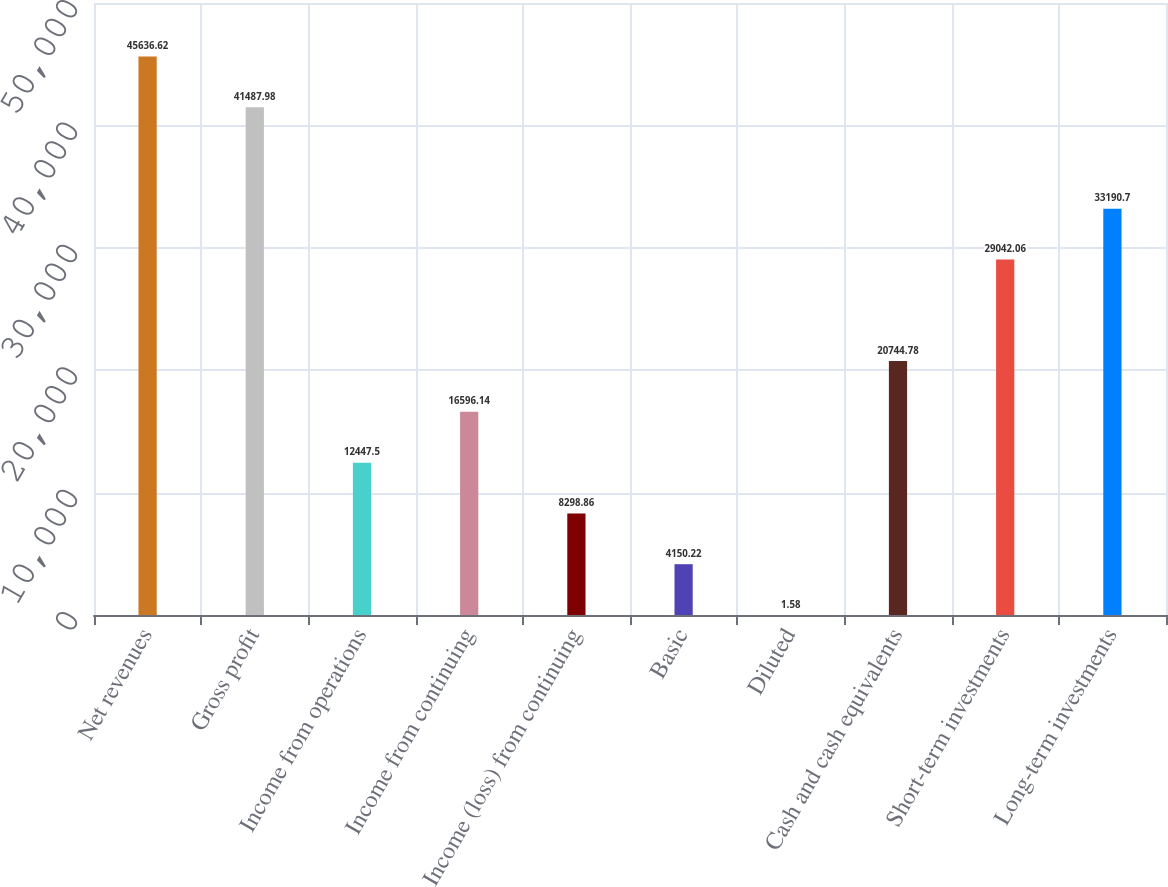<chart> <loc_0><loc_0><loc_500><loc_500><bar_chart><fcel>Net revenues<fcel>Gross profit<fcel>Income from operations<fcel>Income from continuing<fcel>Income (loss) from continuing<fcel>Basic<fcel>Diluted<fcel>Cash and cash equivalents<fcel>Short-term investments<fcel>Long-term investments<nl><fcel>45636.6<fcel>41488<fcel>12447.5<fcel>16596.1<fcel>8298.86<fcel>4150.22<fcel>1.58<fcel>20744.8<fcel>29042.1<fcel>33190.7<nl></chart> 